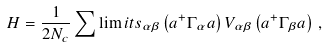Convert formula to latex. <formula><loc_0><loc_0><loc_500><loc_500>H = \frac { 1 } { 2 N _ { c } } \sum \lim i t s _ { \alpha \beta } \left ( a ^ { + } \Gamma _ { \alpha } a \right ) V _ { \alpha \beta } \left ( a ^ { + } \Gamma _ { \beta } a \right ) \, ,</formula> 